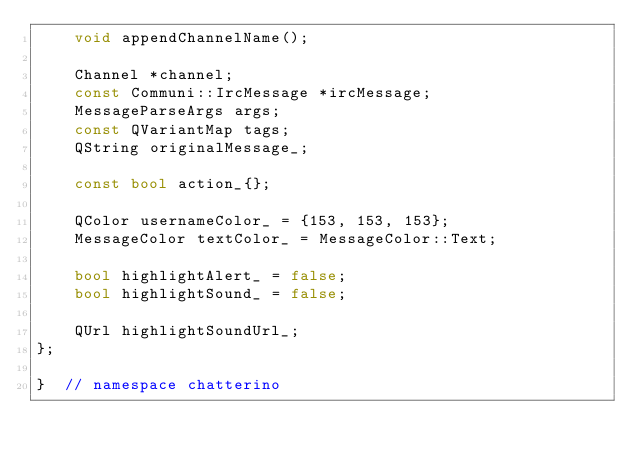<code> <loc_0><loc_0><loc_500><loc_500><_C++_>    void appendChannelName();

    Channel *channel;
    const Communi::IrcMessage *ircMessage;
    MessageParseArgs args;
    const QVariantMap tags;
    QString originalMessage_;

    const bool action_{};

    QColor usernameColor_ = {153, 153, 153};
    MessageColor textColor_ = MessageColor::Text;

    bool highlightAlert_ = false;
    bool highlightSound_ = false;

    QUrl highlightSoundUrl_;
};

}  // namespace chatterino
</code> 